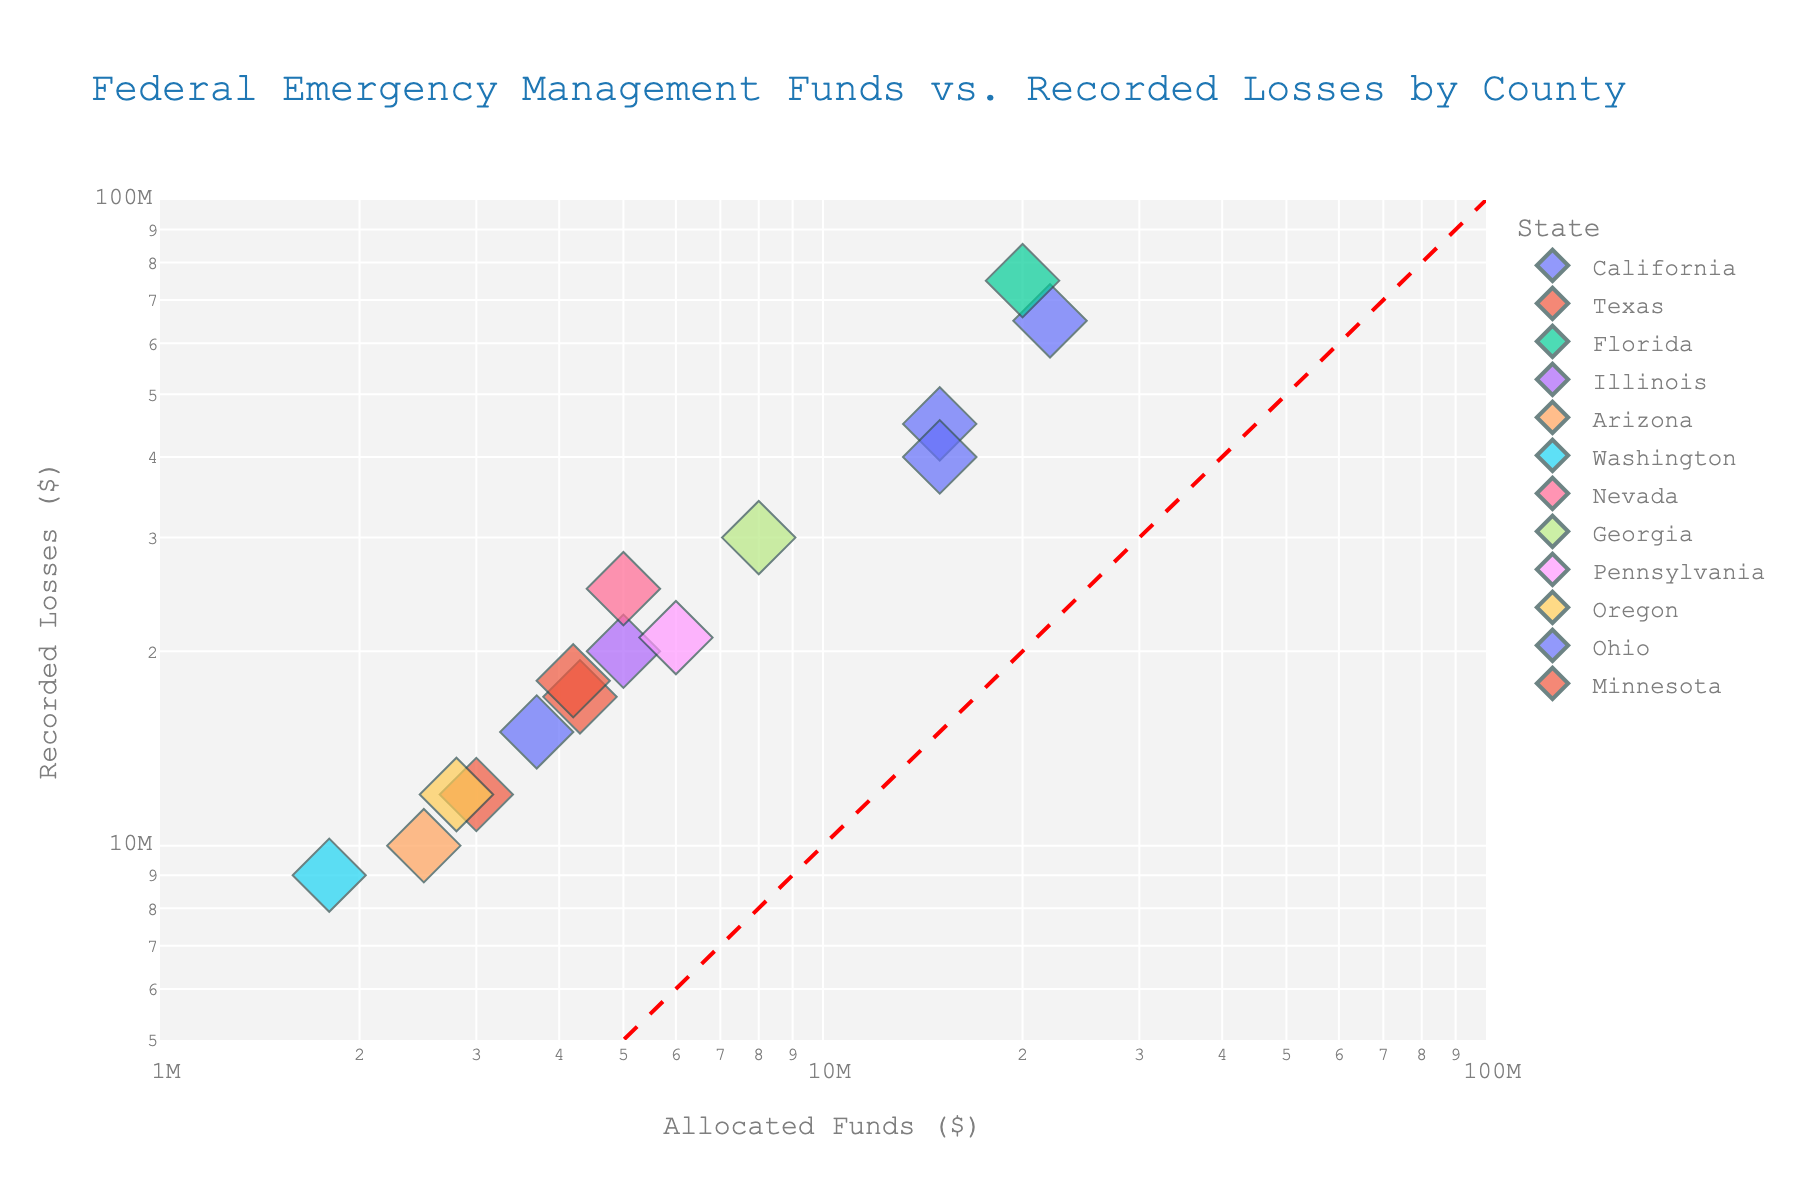Which county received the highest allocation of federal emergency management funds? The scatter plot marks the "Allocated Funds" axis in a log scale. By identifying the point farthest along the x-axis (highest value), it's clear that Miami-Dade, Florida received the highest allocation of funds.
Answer: Miami-Dade What is the title of the scatter plot? The title is prominently displayed at the top of the chart.
Answer: Federal Emergency Management Funds vs. Recorded Losses by County How many counties are represented from the state of California? Each data point is colored according to the state. By counting the points colored for California, we see there are three: Los Angeles, San Diego, and Orange.
Answer: 3 What is the range of values shown on the y-axis? The y-axis uses a log scale with values ranging between \(5 \times 10^6\) and \(10^8\).
Answer: \(5 \times 10^6\) to \(10^8\) Which county has the smallest amount of recorded losses and how much is it? By looking for the data point nearest to the lower edge of the y-axis, King, Washington, can be identified with recorded losses around $9,000,000.
Answer: King, Washington, $9,000,000 Which county had the highest recorded losses, and what was the value? By identifying the data point farthest along the y-axis, Miami-Dade, Florida has the highest recorded losses with an approximate value of $75,000,000.
Answer: Miami-Dade, $75,000,000 Which state has the most consistent ratio of allocated funds to recorded losses? Examining the diagonal line (indicating a 1:1 ratio), states whose points closely follow this line demonstrate consistency. Texas and Florida points are close along the line. However, Texas has points represented closer, indicating more consistent ratios.
Answer: Texas In which year was the median federal fund allocation, and what is the approximate value? Sorting the years and positioning them along the size of each point can give a relative idea of where the median lies. With 15 points, the median year is the 8th in sequence (2012). Fulton, Georgia in 2012 had an approximate allocation of $8,000,000.
Answer: 2012, $8,000,000 Which counties received more than $10,000,000 in allocated funds but had recorded losses less than $50,000,000? By identifying points with x-values greater than $10,000,000 and y-values less than $50,000,000, we find Los Angeles and Orange in California.
Answer: Los Angeles (CA) and Orange (CA) How does the size of the data points relate to the years? The size of the circles in the scatter plot corresponds to the year, with larger sizes indicating later years. This shows a visual progression through time.
Answer: Larger circles represent later years 